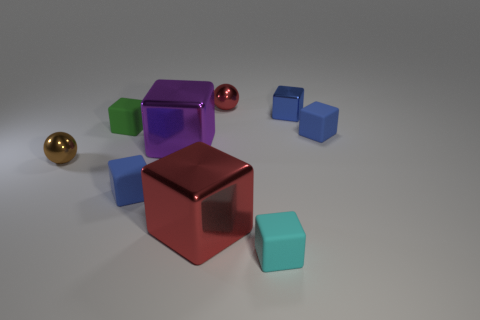Subtract all small blue metallic cubes. How many cubes are left? 6 Subtract 1 spheres. How many spheres are left? 1 Subtract all gray balls. How many blue cubes are left? 3 Subtract all red cubes. How many cubes are left? 6 Subtract all balls. How many objects are left? 7 Add 8 brown metal things. How many brown metal things are left? 9 Add 9 large red metal blocks. How many large red metal blocks exist? 10 Subtract 1 brown spheres. How many objects are left? 8 Subtract all yellow blocks. Subtract all purple spheres. How many blocks are left? 7 Subtract all blue shiny cubes. Subtract all green matte cubes. How many objects are left? 7 